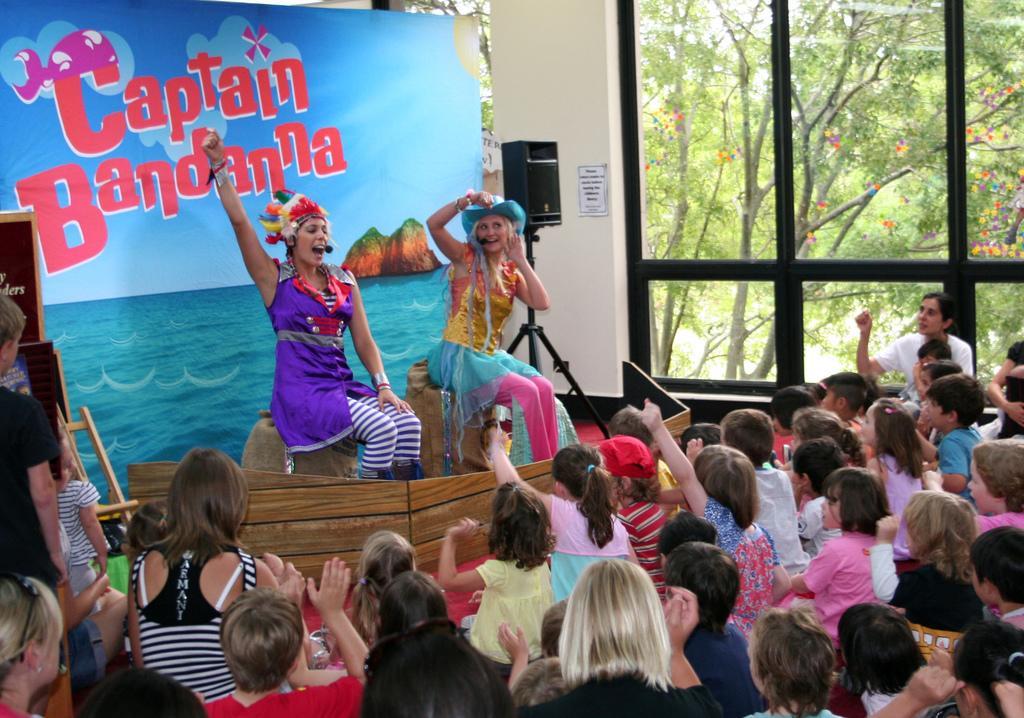In one or two sentences, can you explain what this image depicts? In the center of the image we can see two persons are sitting on the solid structures and they are smiling. And we can see they are in different costumes. In front of them, we can see one wooden object and a few people are sitting and they are in different costumes. In the background there is a wall, glass, one banner, posters, one wooden object, stand and speaker. On the banner, we can see some text. Through the glass, we can see trees. 